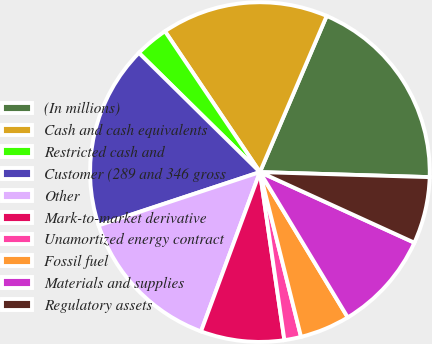Convert chart. <chart><loc_0><loc_0><loc_500><loc_500><pie_chart><fcel>(In millions)<fcel>Cash and cash equivalents<fcel>Restricted cash and<fcel>Customer (289 and 346 gross<fcel>Other<fcel>Mark-to-market derivative<fcel>Unamortized energy contract<fcel>Fossil fuel<fcel>Materials and supplies<fcel>Regulatory assets<nl><fcel>19.04%<fcel>15.87%<fcel>3.18%<fcel>17.46%<fcel>14.28%<fcel>7.94%<fcel>1.59%<fcel>4.76%<fcel>9.52%<fcel>6.35%<nl></chart> 